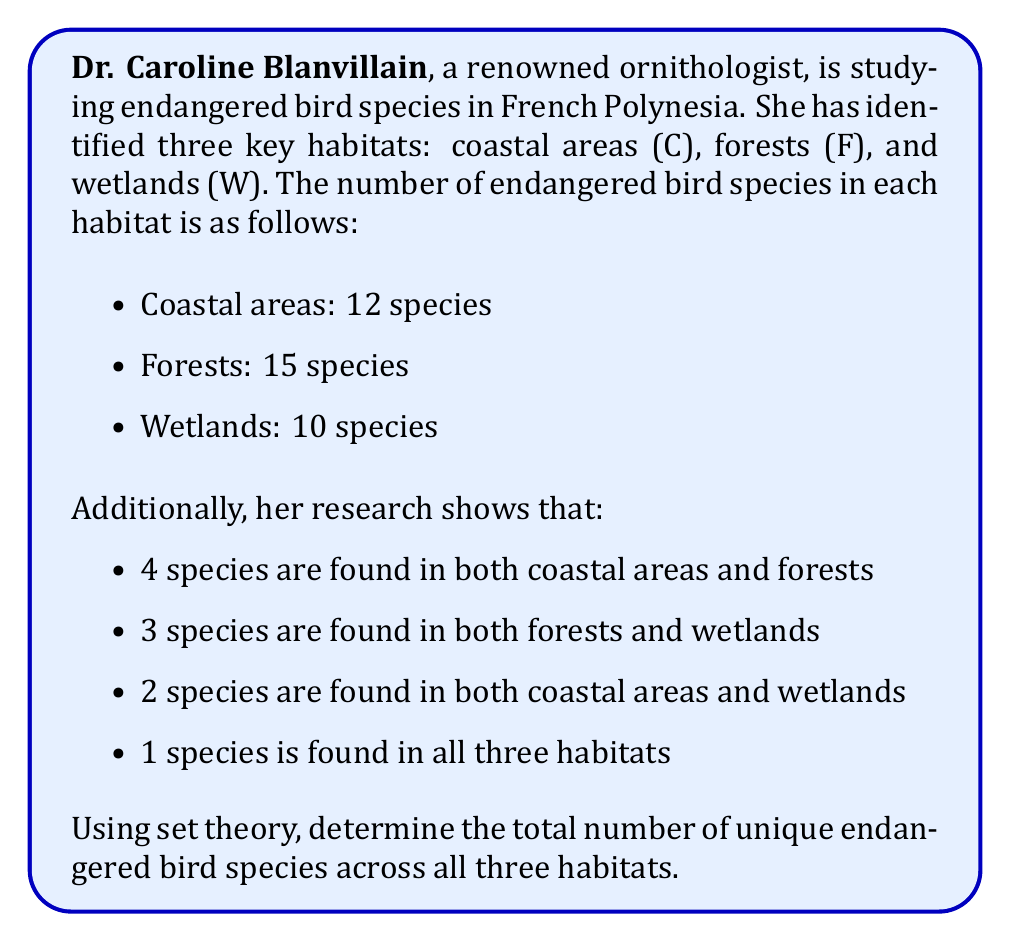Provide a solution to this math problem. Let's approach this problem step-by-step using set theory:

1) Let's define our sets:
   C = set of species in coastal areas
   F = set of species in forests
   W = set of species in wetlands

2) We're given:
   $|C| = 12$, $|F| = 15$, $|W| = 10$
   $|C \cap F| = 4$, $|F \cap W| = 3$, $|C \cap W| = 2$
   $|C \cap F \cap W| = 1$

3) We need to find $|C \cup F \cup W|$. We can use the Inclusion-Exclusion Principle:

   $$|C \cup F \cup W| = |C| + |F| + |W| - |C \cap F| - |F \cap W| - |C \cap W| + |C \cap F \cap W|$$

4) Substituting the values:

   $$|C \cup F \cup W| = 12 + 15 + 10 - 4 - 3 - 2 + 1$$

5) Calculating:

   $$|C \cup F \cup W| = 37 - 9 + 1 = 29$$

Therefore, there are 29 unique endangered bird species across all three habitats.
Answer: 29 species 